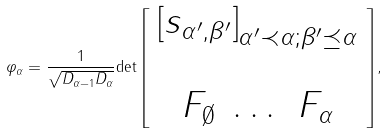<formula> <loc_0><loc_0><loc_500><loc_500>\varphi _ { \alpha } = \frac { 1 } { \sqrt { D _ { \alpha - 1 } D _ { \alpha } } } { \det \left [ \begin{array} { c } \left [ s _ { \alpha ^ { \prime } , \beta ^ { \prime } } \right ] _ { \alpha ^ { \prime } \prec \alpha ; \beta ^ { \prime } \preceq \alpha } \\ \\ \begin{array} { c c c } F _ { \emptyset } & \dots & F _ { \alpha } \end{array} \end{array} \right ] } ,</formula> 